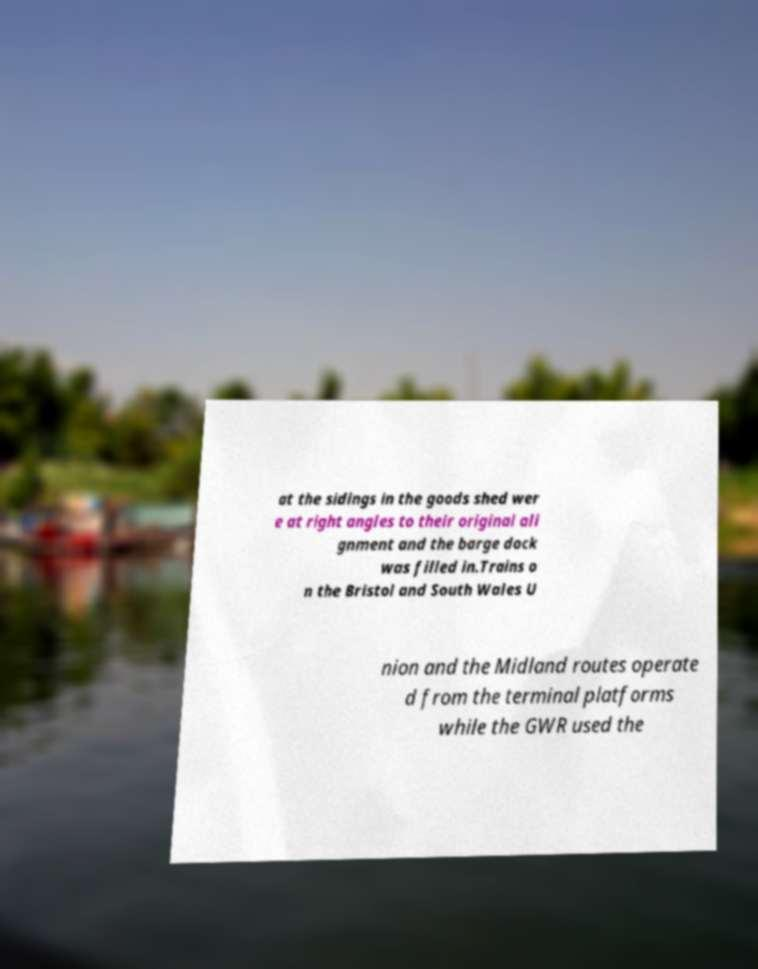Please identify and transcribe the text found in this image. at the sidings in the goods shed wer e at right angles to their original ali gnment and the barge dock was filled in.Trains o n the Bristol and South Wales U nion and the Midland routes operate d from the terminal platforms while the GWR used the 